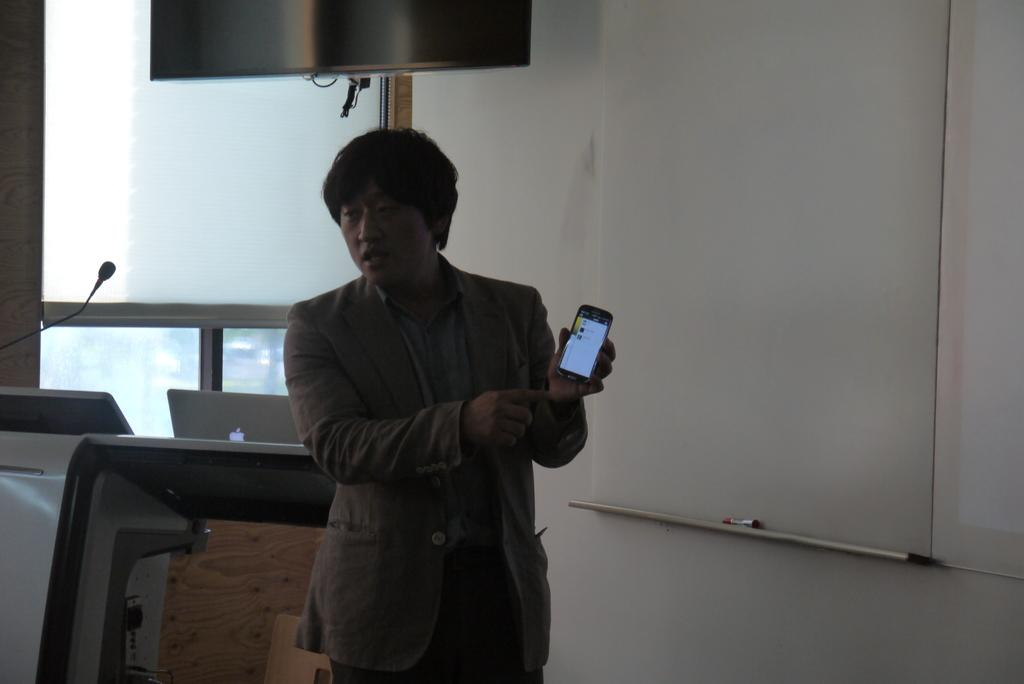Who or what is present in the image? There is a person in the image. What is the person holding? The person is holding a mobile. What can be seen in the background of the image? There is a wall and a window in the background of the image. What is located in the foreground of the image? There is a podium in the image. What is on top of the podium? There is a laptop on the podium. What type of drink is being served during the argument in the image? There is no argument or drink present in the image. Is the person on a skateboard in the image? There is no skateboard or indication of skating in the image. 